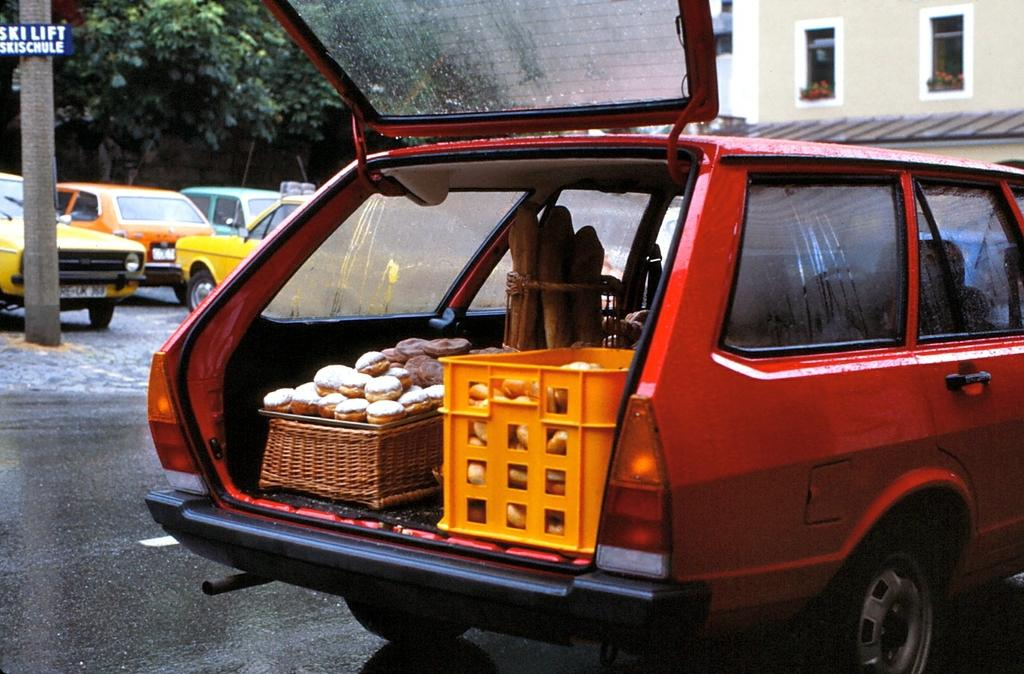<image>
Relay a brief, clear account of the picture shown. A red station wagon has its hatchback open and is parked in front of a sign for a ski lift and ski school. 